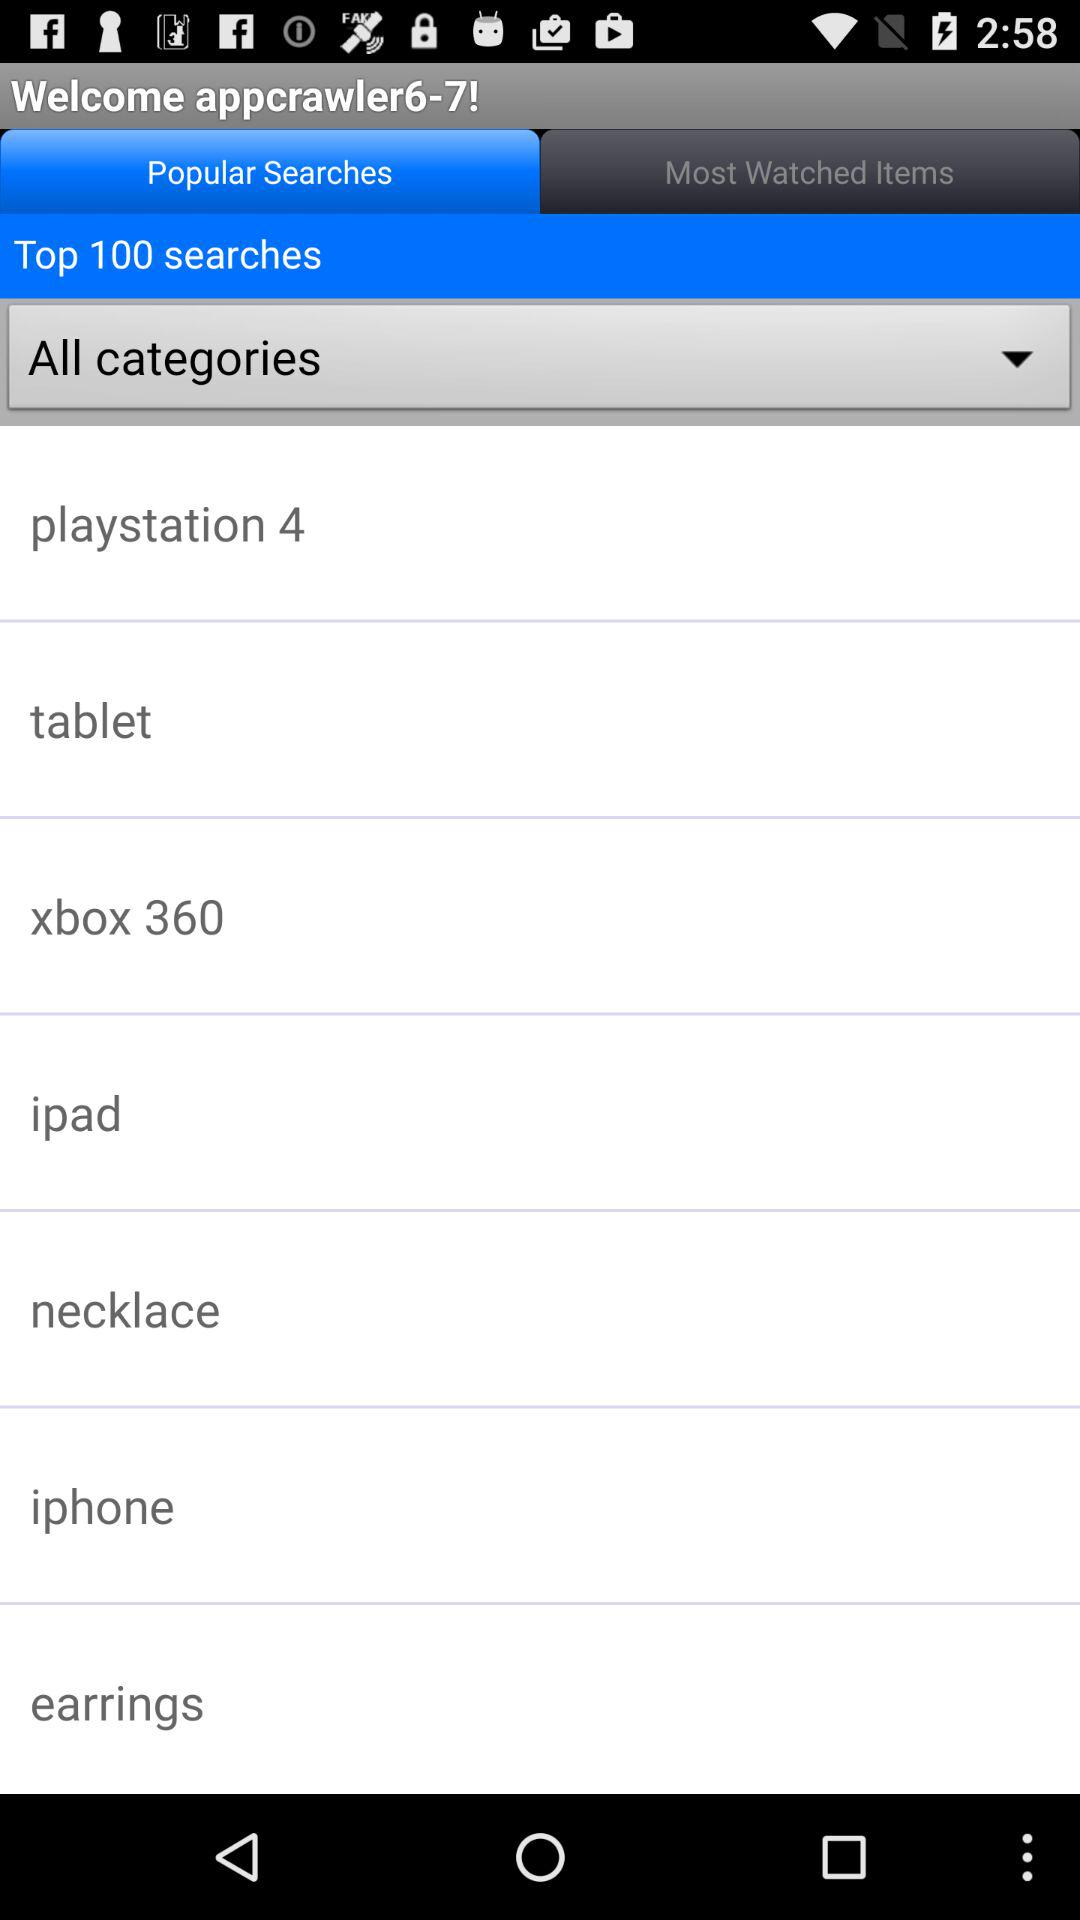How many total numbers of "Top searches" are there? The total number is 100. 